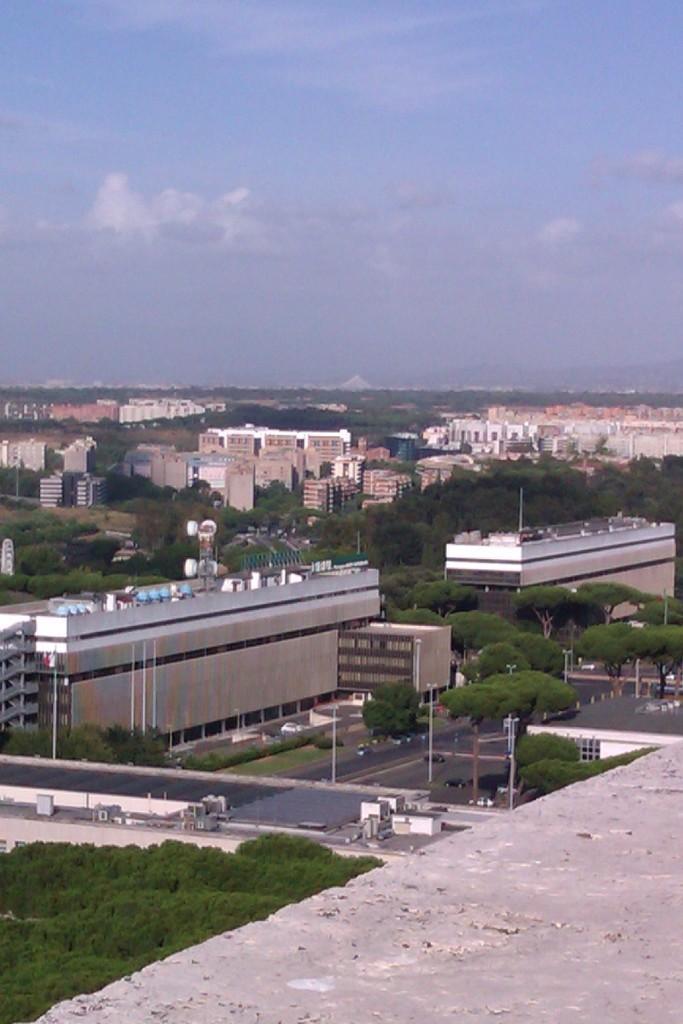Describe this image in one or two sentences. In this image there is the sky, there are buildings, there are trees, there is a tower, there is the grass, there are poles, there are buildings truncated towards the right of the image, there are buildings truncated towards the left of the image. 